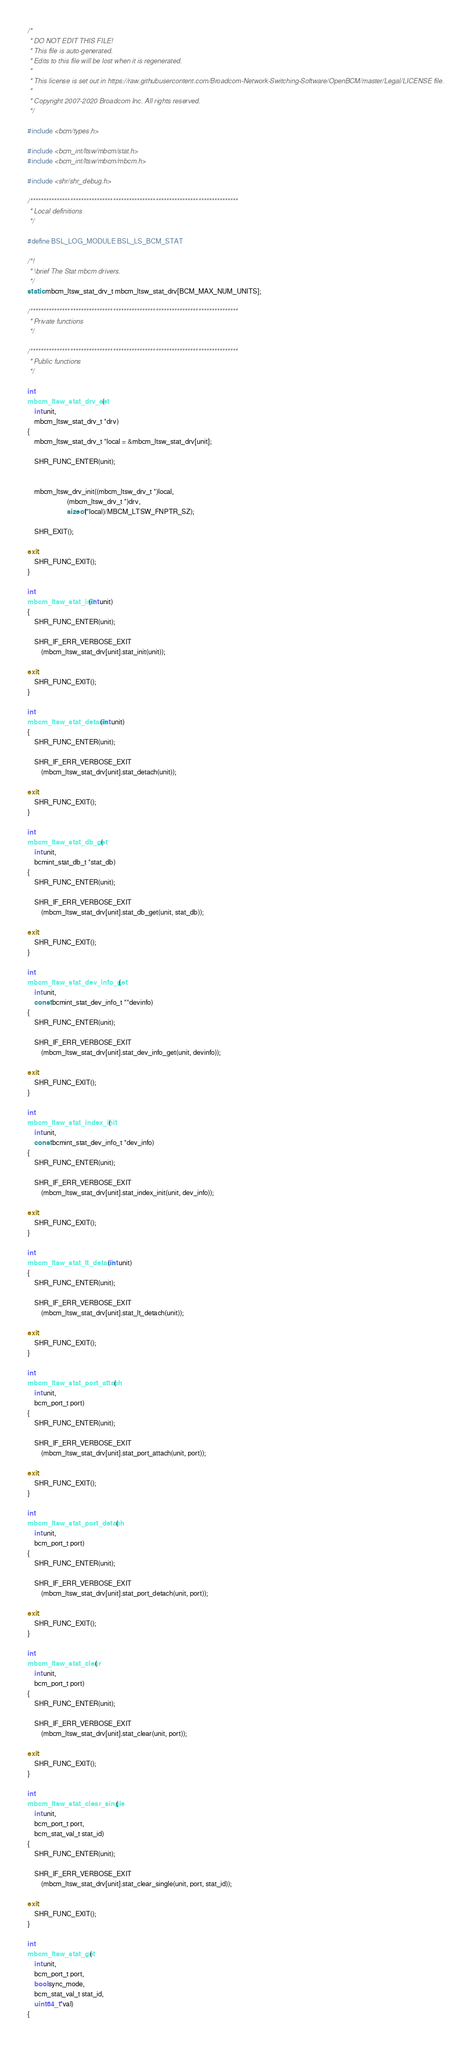<code> <loc_0><loc_0><loc_500><loc_500><_C_>/*
 * DO NOT EDIT THIS FILE!
 * This file is auto-generated.
 * Edits to this file will be lost when it is regenerated.
 *
 * This license is set out in https://raw.githubusercontent.com/Broadcom-Network-Switching-Software/OpenBCM/master/Legal/LICENSE file.
 * 
 * Copyright 2007-2020 Broadcom Inc. All rights reserved.
 */

#include <bcm/types.h>

#include <bcm_int/ltsw/mbcm/stat.h>
#include <bcm_int/ltsw/mbcm/mbcm.h>

#include <shr/shr_debug.h>

/******************************************************************************
 * Local definitions
 */

#define BSL_LOG_MODULE BSL_LS_BCM_STAT

/*!
 * \brief The Stat mbcm drivers.
 */
static mbcm_ltsw_stat_drv_t mbcm_ltsw_stat_drv[BCM_MAX_NUM_UNITS];

/******************************************************************************
 * Private functions
 */

/******************************************************************************
 * Public functions
 */

int
mbcm_ltsw_stat_drv_set(
    int unit,
    mbcm_ltsw_stat_drv_t *drv)
{
    mbcm_ltsw_stat_drv_t *local = &mbcm_ltsw_stat_drv[unit];

    SHR_FUNC_ENTER(unit);


    mbcm_ltsw_drv_init((mbcm_ltsw_drv_t *)local,
                       (mbcm_ltsw_drv_t *)drv,
                       sizeof(*local)/MBCM_LTSW_FNPTR_SZ);

    SHR_EXIT();

exit:
    SHR_FUNC_EXIT();
}

int
mbcm_ltsw_stat_init(int unit)
{
    SHR_FUNC_ENTER(unit);

    SHR_IF_ERR_VERBOSE_EXIT
        (mbcm_ltsw_stat_drv[unit].stat_init(unit));

exit:
    SHR_FUNC_EXIT();
}

int
mbcm_ltsw_stat_detach(int unit)
{
    SHR_FUNC_ENTER(unit);

    SHR_IF_ERR_VERBOSE_EXIT
        (mbcm_ltsw_stat_drv[unit].stat_detach(unit));

exit:
    SHR_FUNC_EXIT();
}

int
mbcm_ltsw_stat_db_get(
    int unit,
    bcmint_stat_db_t *stat_db)
{
    SHR_FUNC_ENTER(unit);

    SHR_IF_ERR_VERBOSE_EXIT
        (mbcm_ltsw_stat_drv[unit].stat_db_get(unit, stat_db));

exit:
    SHR_FUNC_EXIT();
}

int
mbcm_ltsw_stat_dev_info_get(
    int unit,
    const bcmint_stat_dev_info_t **devinfo)
{
    SHR_FUNC_ENTER(unit);

    SHR_IF_ERR_VERBOSE_EXIT
        (mbcm_ltsw_stat_drv[unit].stat_dev_info_get(unit, devinfo));

exit:
    SHR_FUNC_EXIT();
}

int
mbcm_ltsw_stat_index_init(
    int unit,
    const bcmint_stat_dev_info_t *dev_info)
{
    SHR_FUNC_ENTER(unit);

    SHR_IF_ERR_VERBOSE_EXIT
        (mbcm_ltsw_stat_drv[unit].stat_index_init(unit, dev_info));

exit:
    SHR_FUNC_EXIT();
}

int
mbcm_ltsw_stat_lt_detach(int unit)
{
    SHR_FUNC_ENTER(unit);

    SHR_IF_ERR_VERBOSE_EXIT
        (mbcm_ltsw_stat_drv[unit].stat_lt_detach(unit));

exit:
    SHR_FUNC_EXIT();
}

int
mbcm_ltsw_stat_port_attach(
    int unit,
    bcm_port_t port)
{
    SHR_FUNC_ENTER(unit);

    SHR_IF_ERR_VERBOSE_EXIT
        (mbcm_ltsw_stat_drv[unit].stat_port_attach(unit, port));

exit:
    SHR_FUNC_EXIT();
}

int
mbcm_ltsw_stat_port_detach(
    int unit,
    bcm_port_t port)
{
    SHR_FUNC_ENTER(unit);

    SHR_IF_ERR_VERBOSE_EXIT
        (mbcm_ltsw_stat_drv[unit].stat_port_detach(unit, port));

exit:
    SHR_FUNC_EXIT();
}

int
mbcm_ltsw_stat_clear(
    int unit,
    bcm_port_t port)
{
    SHR_FUNC_ENTER(unit);

    SHR_IF_ERR_VERBOSE_EXIT
        (mbcm_ltsw_stat_drv[unit].stat_clear(unit, port));

exit:
    SHR_FUNC_EXIT();
}

int
mbcm_ltsw_stat_clear_single(
    int unit,
    bcm_port_t port,
    bcm_stat_val_t stat_id)
{
    SHR_FUNC_ENTER(unit);

    SHR_IF_ERR_VERBOSE_EXIT
        (mbcm_ltsw_stat_drv[unit].stat_clear_single(unit, port, stat_id));

exit:
    SHR_FUNC_EXIT();
}

int
mbcm_ltsw_stat_get(
    int unit,
    bcm_port_t port,
    bool sync_mode,
    bcm_stat_val_t stat_id,
    uint64_t *val)
{</code> 